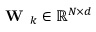<formula> <loc_0><loc_0><loc_500><loc_500>W _ { k } \in \mathbb { R } ^ { N \times d }</formula> 